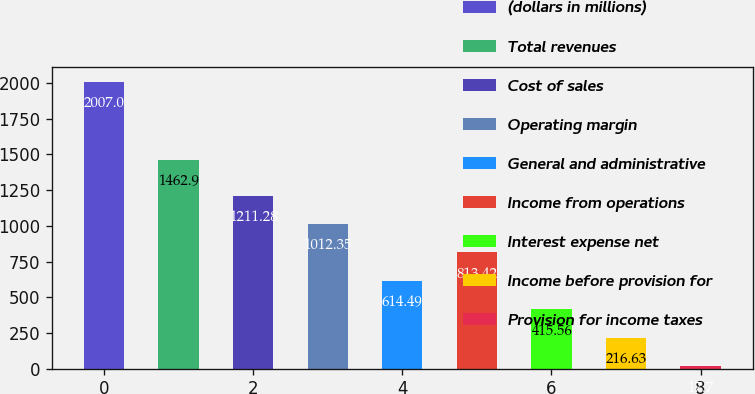Convert chart to OTSL. <chart><loc_0><loc_0><loc_500><loc_500><bar_chart><fcel>(dollars in millions)<fcel>Total revenues<fcel>Cost of sales<fcel>Operating margin<fcel>General and administrative<fcel>Income from operations<fcel>Interest expense net<fcel>Income before provision for<fcel>Provision for income taxes<nl><fcel>2007<fcel>1462.9<fcel>1211.28<fcel>1012.35<fcel>614.49<fcel>813.42<fcel>415.56<fcel>216.63<fcel>17.7<nl></chart> 